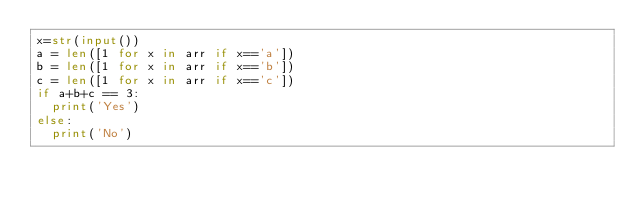<code> <loc_0><loc_0><loc_500><loc_500><_Python_>x=str(input())
a = len([1 for x in arr if x=='a'])
b = len([1 for x in arr if x=='b'])
c = len([1 for x in arr if x=='c'])
if a+b+c == 3:
  print('Yes')
else:
  print('No')</code> 